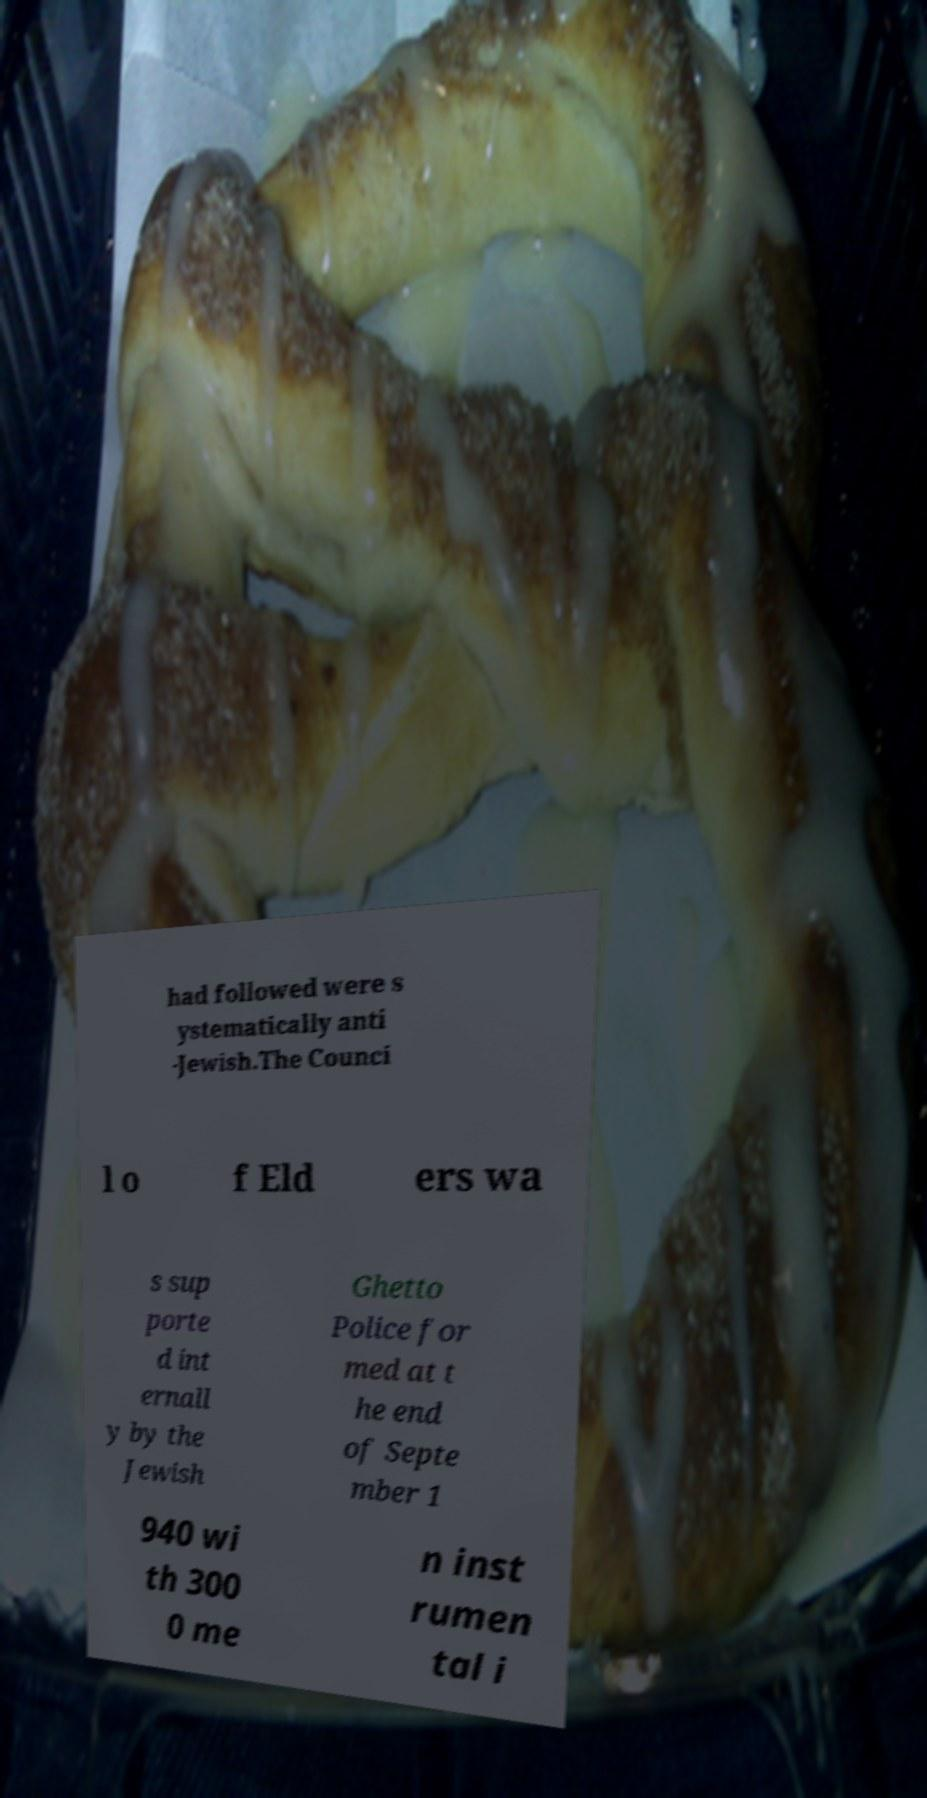What messages or text are displayed in this image? I need them in a readable, typed format. had followed were s ystematically anti -Jewish.The Counci l o f Eld ers wa s sup porte d int ernall y by the Jewish Ghetto Police for med at t he end of Septe mber 1 940 wi th 300 0 me n inst rumen tal i 